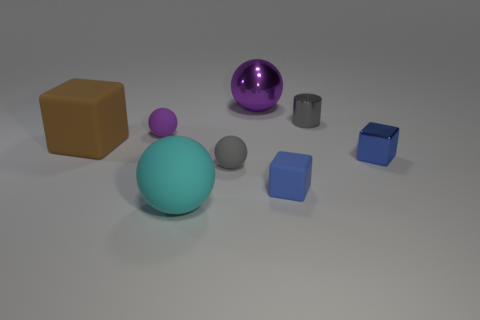What can you infer about the lighting source in this scene? The lighting in the scene appears to be diffused, with soft shadows pointing away from the objects, suggesting an overhead light source that is not directly visible. This creates a gentle illumination that softly highlights the shapes and textures of the objects. What does the shadow tell us about the form of the objects? The shadows conform to the shapes of the objects, providing clues about their three-dimensional form. For instance, the elongated shadows of the cubes indicate their square bases, while the shorter, circular shadow corresponds to the sphere's rounded surface. 